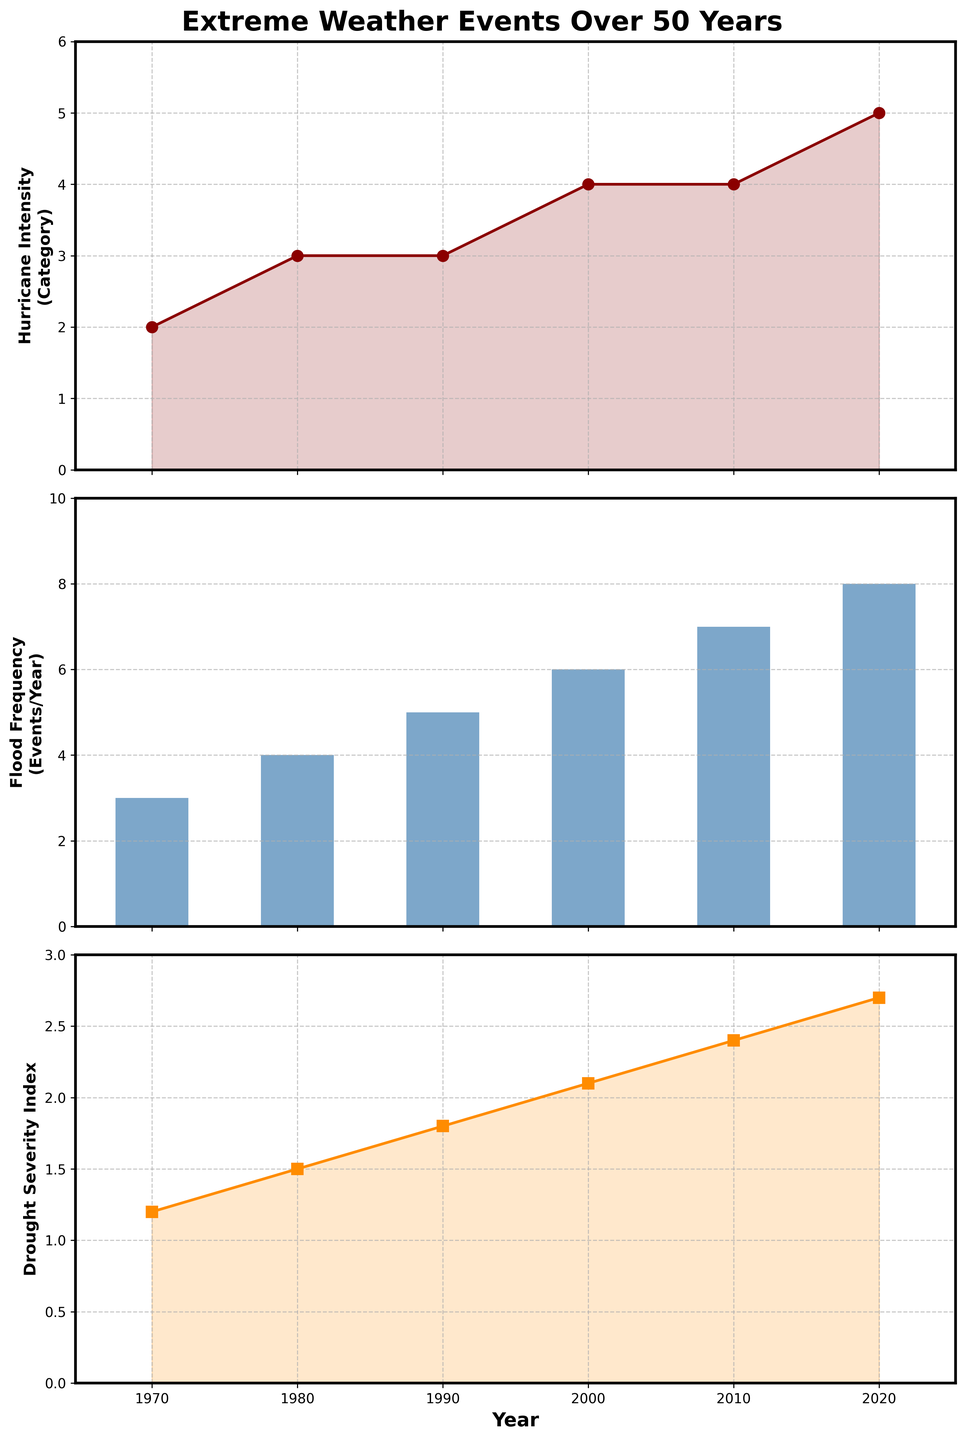What is the title of the figure? The figure's title is displayed at the top of the plot. It reads 'Extreme Weather Events Over 50 Years'.
Answer: Extreme Weather Events Over 50 Years How many subplots are there in the figure? By visually scanning the figure, you can see that there are three distinct subplots aligned vertically.
Answer: Three What is the color of the line representing Hurricane Intensity? The plot for Hurricane Intensity uses a dark red color for the line and markers.
Answer: Dark red Which axis represents the years in all subplots? In all three subplots, the years are represented on the x-axis, which is common across all of them.
Answer: x-axis In what year did Hurricane Intensity reach category 5 for the first time? By observing the Hurricane Intensity plot, you can see that category 5 is reached in the year 2020.
Answer: 2020 Which event had the highest number of occurrences in any single year, and in which year? By examining the Flood Frequency subplot, you can see that it reached its highest value of 8 events/year in 2020, more than any other event in a single year.
Answer: Floods in 2020 What is the average Flood Frequency over the 50-year period? Sum the values for Flood Frequency (3, 4, 5, 6, 7, 8) and divide by the number of years (6). (3+4+5+6+7+8)/6 = 33/6 = 5.5
Answer: 5.5 How has the Drought Severity Index changed from 1970 to 2020? The Drought Severity Index has steadily increased from 1.2 in 1970 to 2.7 in 2020.
Answer: Increased In which year was there a simultaneous increase in both Hurricane Intensity and Flood Frequency? Comparing the trends, both Hurricane Intensity and Flood Frequency increased in the year 2000.
Answer: 2000 Is there a year where both Flood Frequency and Drought Severity Index show the same value? Comparing the exact values, there is no year in which Flood Frequency and Drought Severity Index have the same numerical value.
Answer: No 